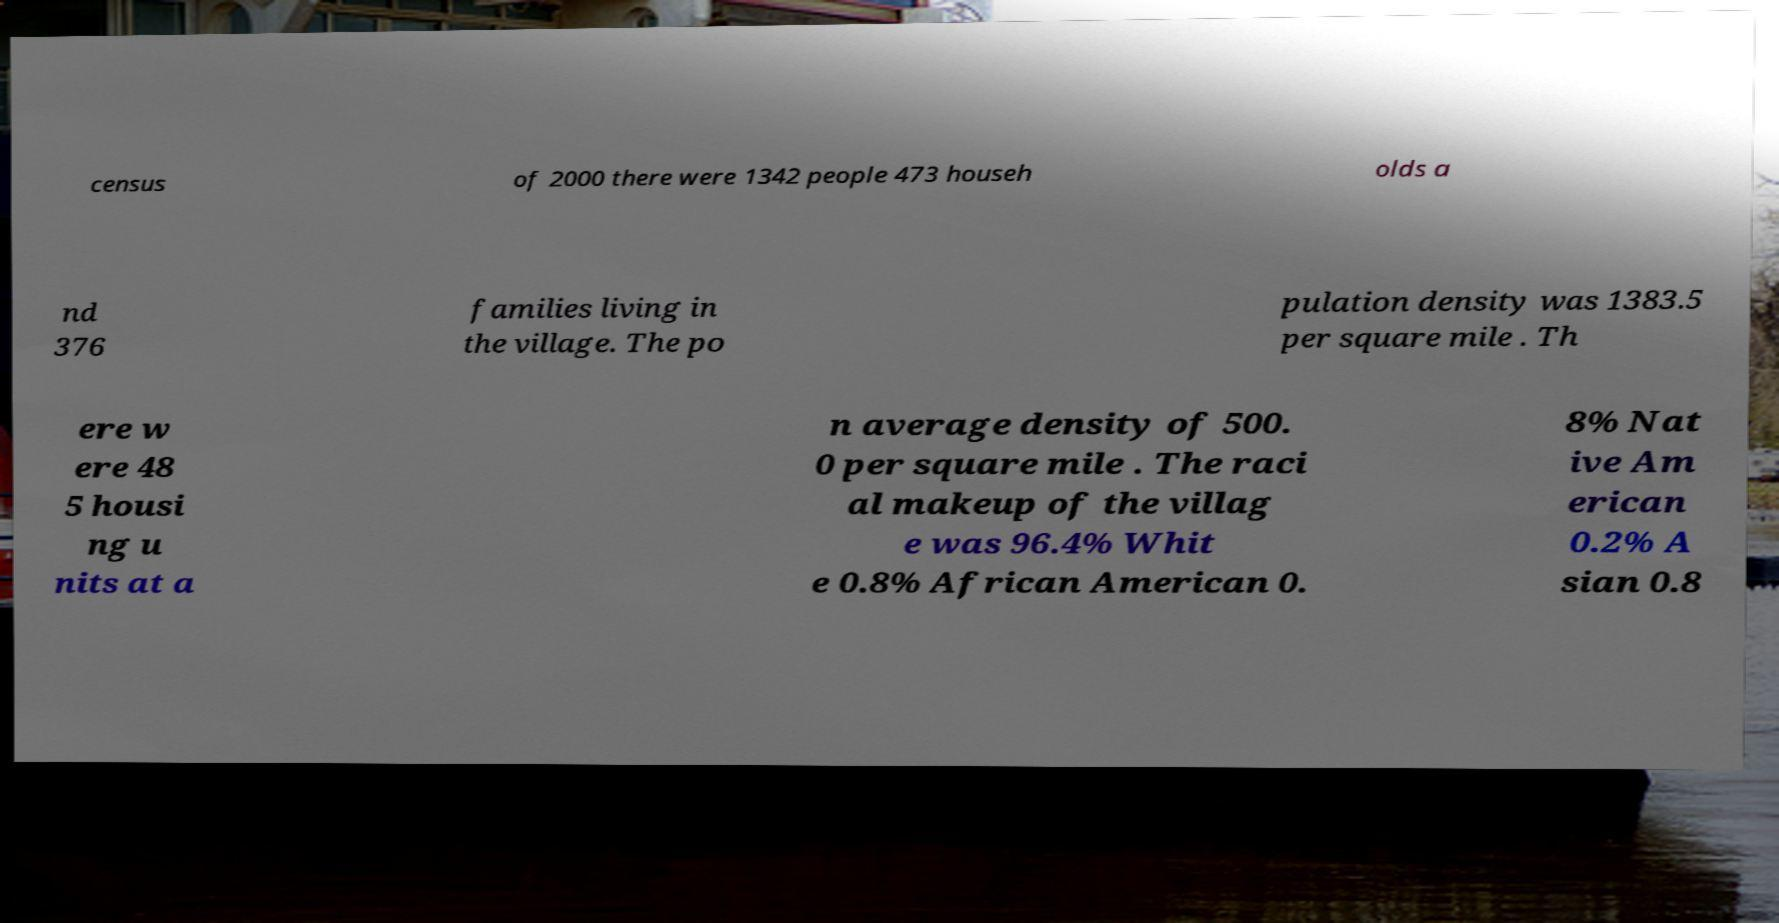For documentation purposes, I need the text within this image transcribed. Could you provide that? census of 2000 there were 1342 people 473 househ olds a nd 376 families living in the village. The po pulation density was 1383.5 per square mile . Th ere w ere 48 5 housi ng u nits at a n average density of 500. 0 per square mile . The raci al makeup of the villag e was 96.4% Whit e 0.8% African American 0. 8% Nat ive Am erican 0.2% A sian 0.8 